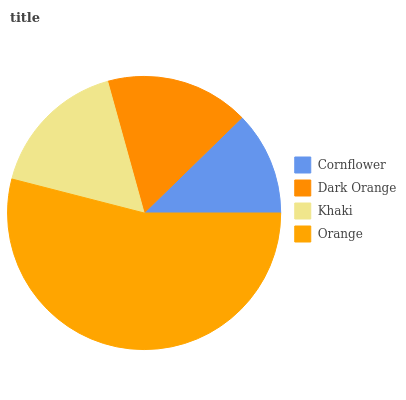Is Cornflower the minimum?
Answer yes or no. Yes. Is Orange the maximum?
Answer yes or no. Yes. Is Dark Orange the minimum?
Answer yes or no. No. Is Dark Orange the maximum?
Answer yes or no. No. Is Dark Orange greater than Cornflower?
Answer yes or no. Yes. Is Cornflower less than Dark Orange?
Answer yes or no. Yes. Is Cornflower greater than Dark Orange?
Answer yes or no. No. Is Dark Orange less than Cornflower?
Answer yes or no. No. Is Dark Orange the high median?
Answer yes or no. Yes. Is Khaki the low median?
Answer yes or no. Yes. Is Khaki the high median?
Answer yes or no. No. Is Cornflower the low median?
Answer yes or no. No. 